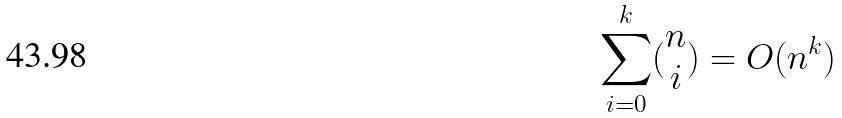Convert formula to latex. <formula><loc_0><loc_0><loc_500><loc_500>\sum _ { i = 0 } ^ { k } ( \begin{matrix} n \\ i \end{matrix} ) = O ( n ^ { k } )</formula> 